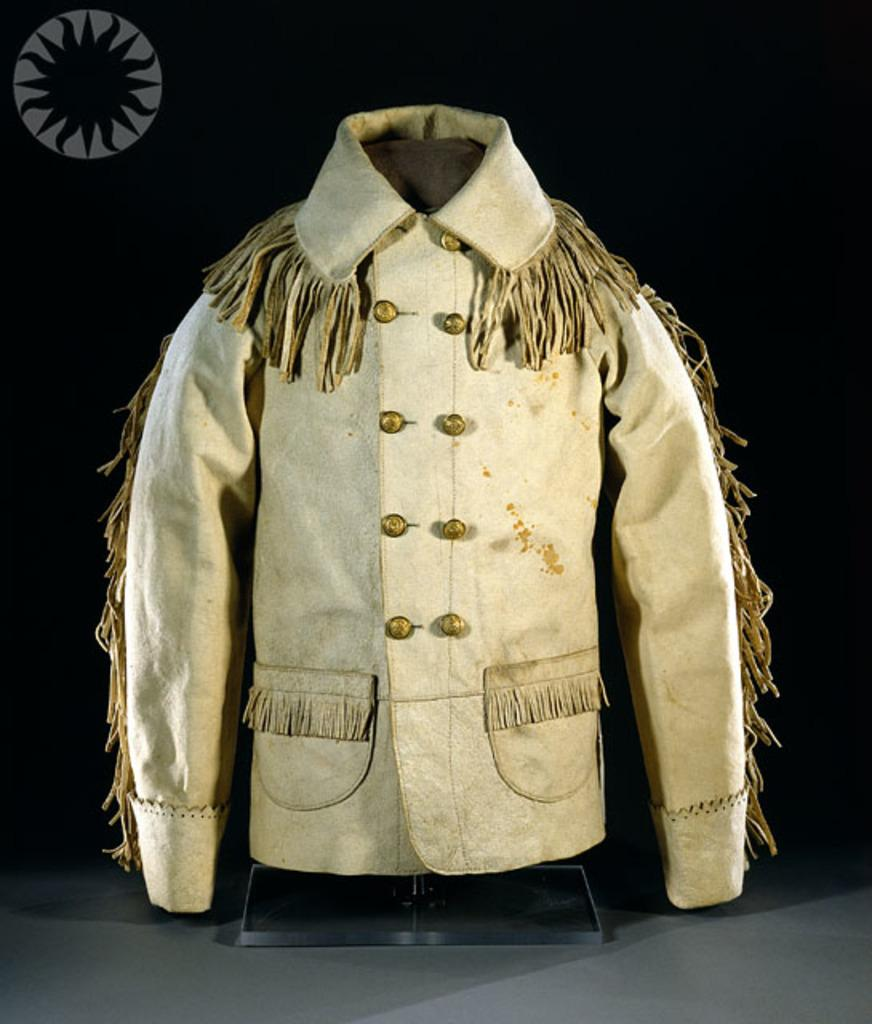What is the color of the jacket in the foreground of the image? The jacket in the foreground of the image is white. How would you describe the background of the image? The background of the image has a dark view. How many snakes are crawling on the white jacket in the image? There are no snakes present in the image; the focus is on the white jacket in the foreground. 